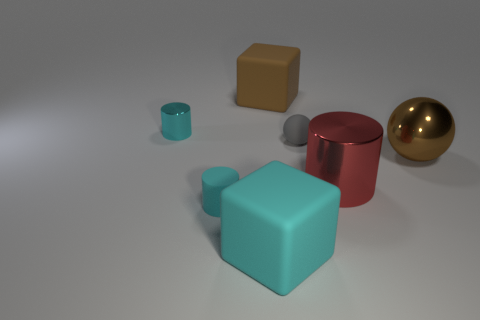There is a object that is both right of the big cyan matte object and behind the gray matte thing; what shape is it?
Your answer should be compact. Cube. Is the number of large blocks that are behind the cyan rubber block less than the number of small cyan metal cylinders?
Your answer should be compact. No. What number of big objects are green rubber cylinders or rubber spheres?
Provide a short and direct response. 0. How big is the brown block?
Your answer should be very brief. Large. Is there any other thing that has the same material as the small sphere?
Make the answer very short. Yes. There is a metallic ball; what number of rubber cubes are in front of it?
Your answer should be compact. 1. There is another thing that is the same shape as the large brown rubber object; what is its size?
Provide a short and direct response. Large. What is the size of the shiny thing that is both to the left of the big brown metal thing and behind the red thing?
Offer a terse response. Small. Does the big metal cylinder have the same color as the rubber cube in front of the large metal ball?
Give a very brief answer. No. What number of green things are shiny cylinders or rubber balls?
Make the answer very short. 0. 